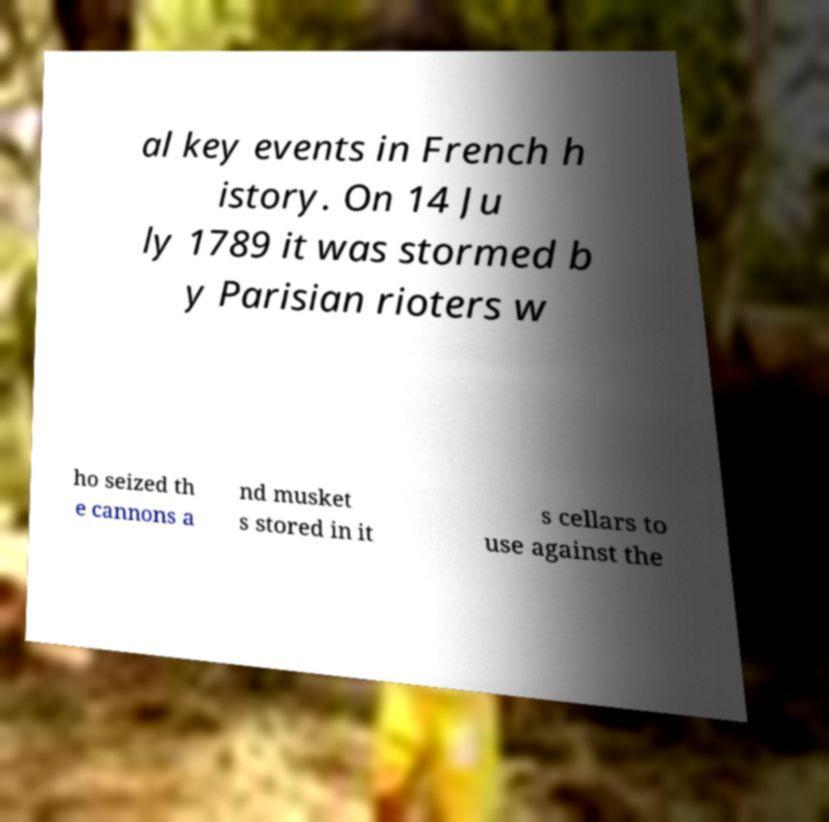For documentation purposes, I need the text within this image transcribed. Could you provide that? al key events in French h istory. On 14 Ju ly 1789 it was stormed b y Parisian rioters w ho seized th e cannons a nd musket s stored in it s cellars to use against the 